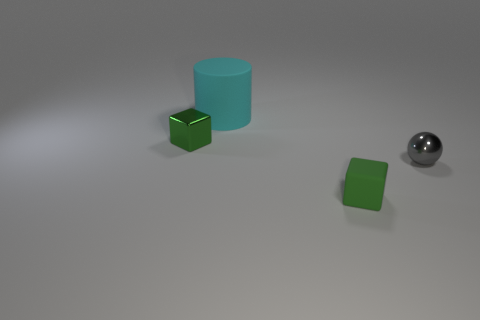What color is the shiny thing that is on the left side of the rubber thing behind the tiny rubber block?
Offer a very short reply. Green. What number of cylinders are either green objects or big cyan things?
Keep it short and to the point. 1. What number of objects are behind the green metallic thing and in front of the gray thing?
Give a very brief answer. 0. The tiny cube to the right of the tiny shiny block is what color?
Offer a terse response. Green. There is a green object that is the same material as the small gray thing; what size is it?
Your answer should be very brief. Small. There is a shiny object left of the gray object; how many matte cylinders are behind it?
Make the answer very short. 1. There is a metallic sphere; how many small green things are left of it?
Your answer should be compact. 2. There is a small cube in front of the tiny object that is on the right side of the small green block in front of the green metallic cube; what is its color?
Your answer should be compact. Green. There is a object that is on the right side of the small rubber thing; is its color the same as the small metal thing that is on the left side of the gray object?
Provide a short and direct response. No. There is a matte thing that is behind the tiny object that is right of the matte block; what shape is it?
Provide a succinct answer. Cylinder. 